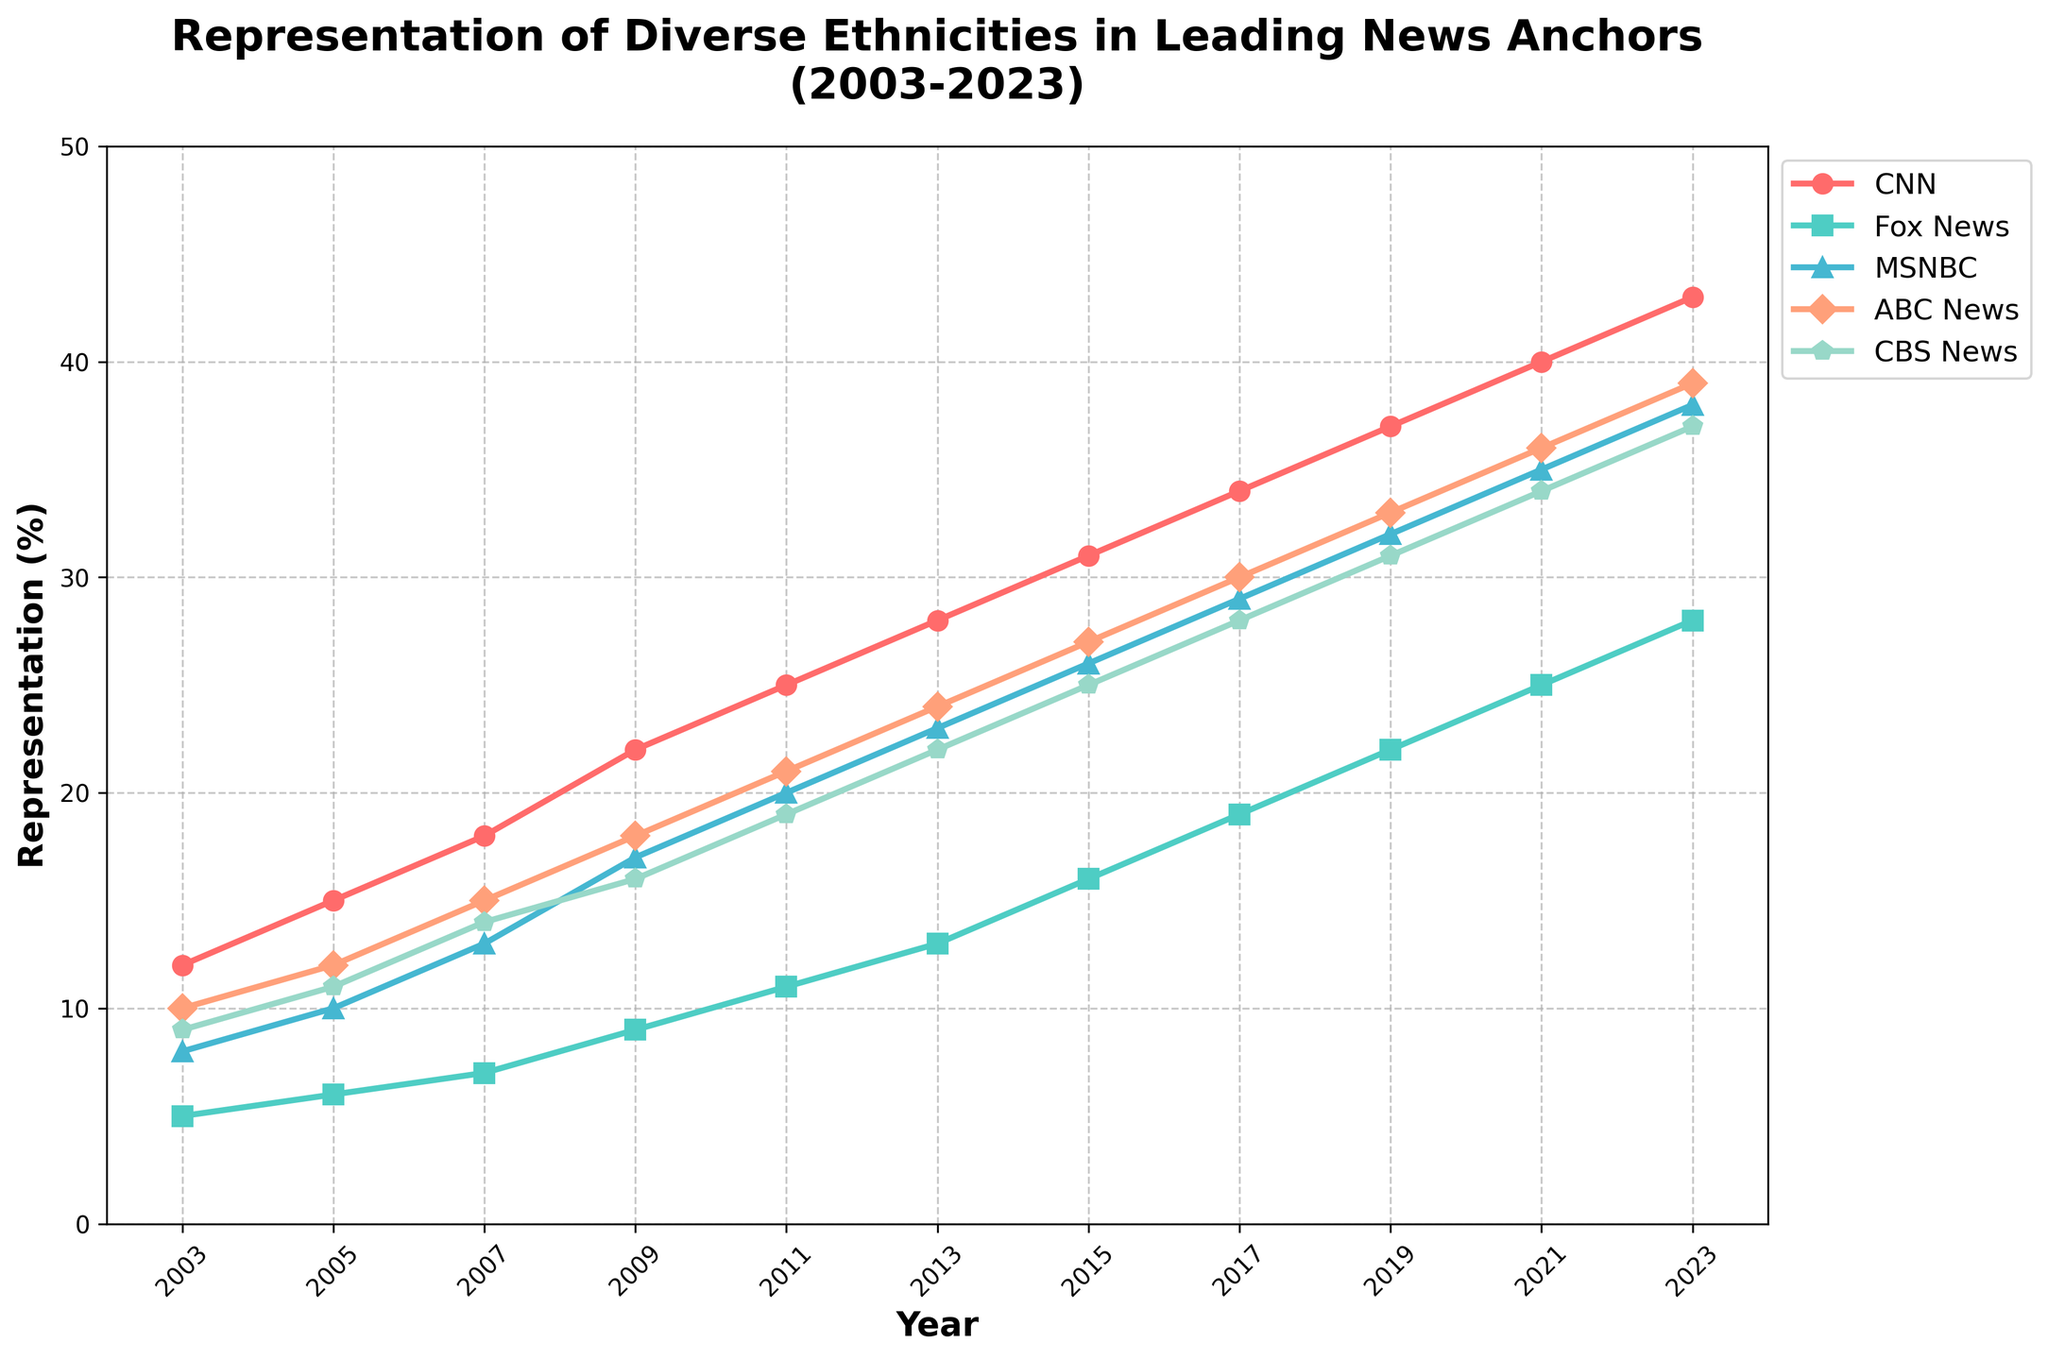What is the trend for CNN's representation over the 20 years? To determine the trend for CNN's representation, look at the line representing CNN on the chart. The line starts at 12% in 2003 and increases steadily to 43% in 2023. Therefore, the trend for CNN is an upward increase over the 20-year period.
Answer: Upward trend Which year did Fox News have the lowest representation? Identify the line for Fox News and locate the lowest point. This point occurs at the beginning: 5% in 2003.
Answer: 2003 In 2011, which news network had the highest representation? Focus on the year 2011 and compare the values of all the networks. CNN has the highest representation with 25%, as it is the highest point relative to other networks for that year.
Answer: CNN How many news networks had representations exceeding 30% in 2023? For the year 2023, look at each network's representation. The values are: CNN (43%), Fox News (28%), MSNBC (38%), ABC News (39%), and CBS News (37%). Count the number of networks with values above 30%. There are four networks: CNN, MSNBC, ABC News, and CBS News.
Answer: 4 Which news network showed the greatest increase in representation from 2003 to 2023? Calculate the increase for each network from 2003 to 2023: CNN (43 - 12 = 31), Fox News (28 - 5 = 23), MSNBC (38 - 8 = 30), ABC News (39 - 10 = 29), CBS News (37 - 9 = 28). CNN has the greatest increase (31%).
Answer: CNN What was the average representation of MSNBC from 2003 to 2023? Add MSNBC's values: 8 + 10 + 13 + 17 + 20 + 23 + 26 + 29 + 32 + 35 + 38 = 251. Divide by the number of data points (11). The average is 251 / 11 ≈ 22.8.
Answer: 22.8 Which news network had the smallest growth rate between 2003 and 2023? Calculate the change in representation for each network: CNN (31), Fox News (23), MSNBC (30), ABC News (29), CBS News (28). Fox News has the smallest increase (23%).
Answer: Fox News Compare the representation of ABC News and CBS News in 2017. Which has higher representation and by how much? Find the values for ABC News and CBS News in 2017: ABC News (30%) and CBS News (28%). Subtract the smaller value from the larger value (30 - 28 = 2). ABC News has a 2% higher representation than CBS News in 2017.
Answer: ABC News by 2% What is the representation discrepancy between the highest and lowest represented news networks in 2021? For 2021, find the highest and lowest representations: CNN (40%) and Fox News (25%). Subtract the lowest value from the highest (40 - 25 = 15). The representation discrepancy is 15%.
Answer: 15 From 2009 to 2013, by how much did MSNBC's representation change? Look at MSNBC's values in 2009 and 2013: 17% in 2009 and 23% in 2013. Subtract the earlier value from the later value (23 - 17 = 6). The change in representation is 6%.
Answer: 6 